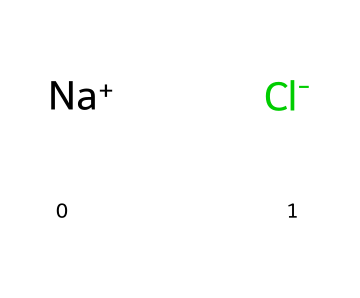What is the overall charge of the sodium chloride unit? The chemical structure includes Na+ (sodium ion) and Cl- (chloride ion). The positive charge of Na+ and the negative charge of Cl- balance each other, resulting in a neutral overall charge for the sodium chloride unit.
Answer: neutral How many types of ions are present in sodium chloride? The structure contains two distinct ions: Na+ and Cl-. These represent the sodium cation and the chloride anion, respectively, indicating that there are two types of ions.
Answer: two What type of lattice structure does sodium chloride form? Sodium chloride crystallizes in a face-centered cubic (FCC) lattice structure, where each sodium ion is surrounded by six chloride ions and vice versa, reflecting its cubic symmetry.
Answer: face-centered cubic What is the primary bond type in sodium chloride? The bond between Na+ and Cl- ions is an ionic bond, characterized by the electrostatic attraction between oppositely charged ions, which is fundamental in the solid state of sodium chloride.
Answer: ionic bond What is the coordination number for sodium in sodium chloride? Each sodium ion (Na+) is surrounded by six chloride ions (Cl-) in the crystal lattice, which indicates that the coordination number of sodium in sodium chloride is six.
Answer: six How many sodium ions are in the crystal lattice for every chloride ion? In a one-to-one ratio of Na+ to Cl-, there is one sodium ion for every chloride ion in the crystal lattice of sodium chloride.
Answer: one What happens to the crystal structure of sodium chloride when dissolved in water? When dissolved in water, the ionic bonds between sodium and chloride ions break as water molecules attract and surround the ions, leading to their dissociation into Na+ and Cl- ions, thus disrupting the solid crystal structure.
Answer: dissociation 